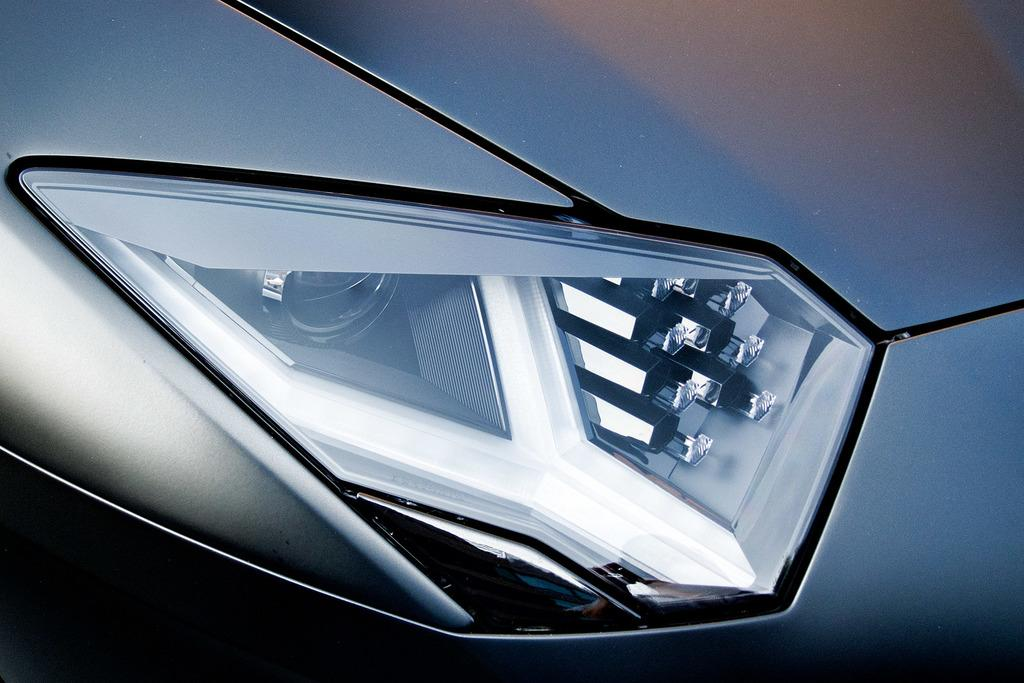What is the main subject of the image? The main subject of the image is the headlight of a vehicle. How many cherries are on the foot of the person in the image? There is no person or cherries present in the image; it only features the headlight of a vehicle. 